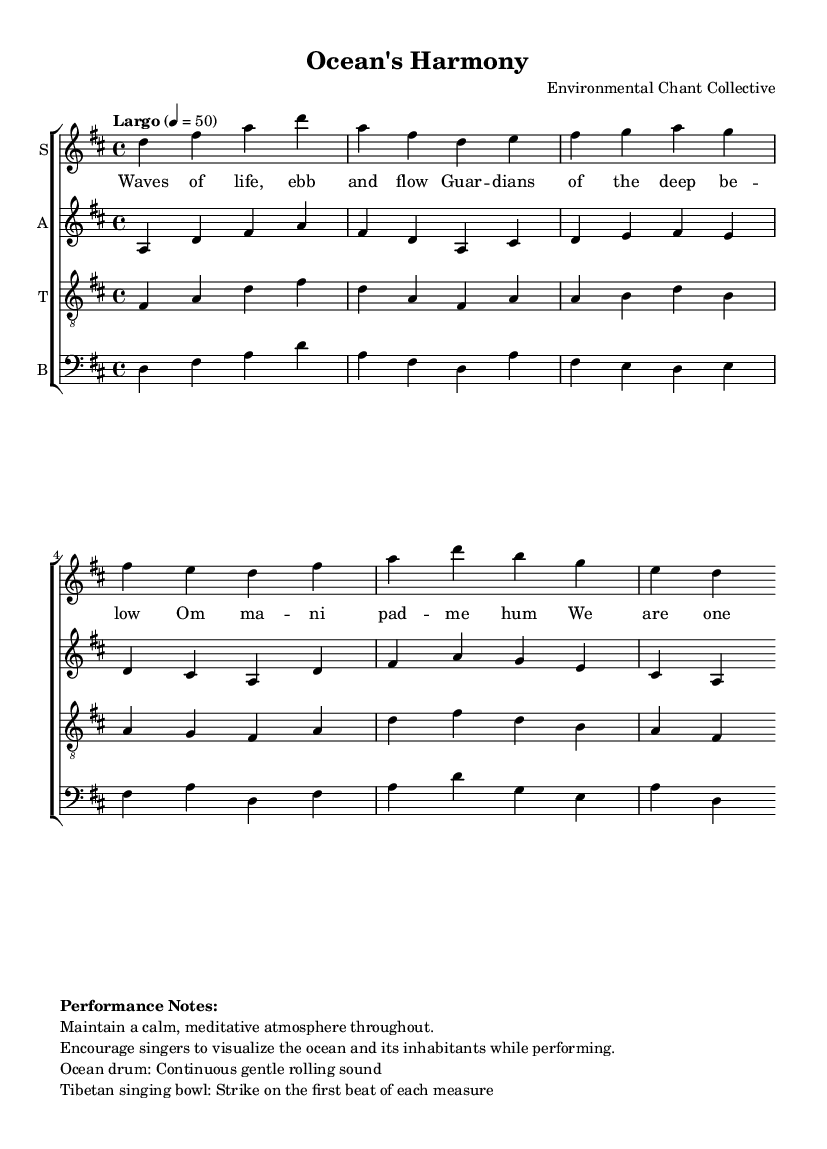What is the key signature of this music? The key signature indicates that there are two sharps, which corresponds to D major.
Answer: D major What is the time signature of this piece? The time signature is indicated as 4/4, meaning there are four beats in each measure.
Answer: 4/4 What is the tempo marking for this chant? The tempo marking states "Largo" with a metronome marking of 4 = 50, suggesting a slow pace.
Answer: Largo How many verses are present in the chant? The sheet music contains one verse and a chorus, counting as one main section.
Answer: One In which section do the lyrics "Om ma -- ni pad -- me hum" appear? These lyrics are part of the chorus, which emphasizes unity with the ocean's song.
Answer: Chorus What instruments are used in the performance notes? The performance notes specify an ocean drum and a Tibetan singing bowl, enhancing the meditative atmosphere.
Answer: Ocean drum and Tibetan singing bowl What is the purpose of maintaining a calm, meditative atmosphere? The notes suggest that a calm atmosphere aids visualization of the ocean and its inhabitants during the performance.
Answer: Visualization aid 